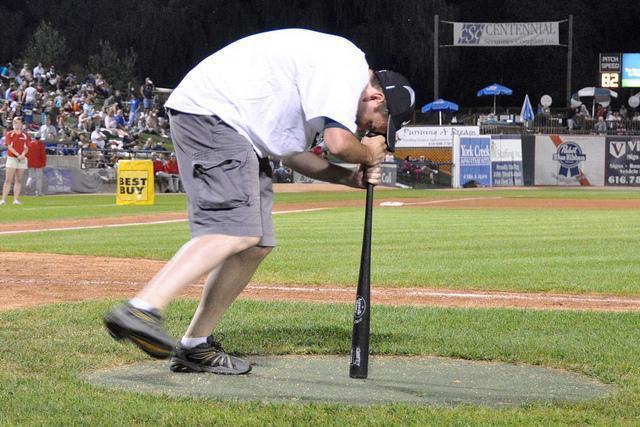How many people are there?
Give a very brief answer. 2. How many clear bottles of wine are on the table?
Give a very brief answer. 0. 